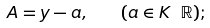<formula> <loc_0><loc_0><loc_500><loc_500>A = y - a , \quad ( a \in K \ \mathbb { R } ) ;</formula> 